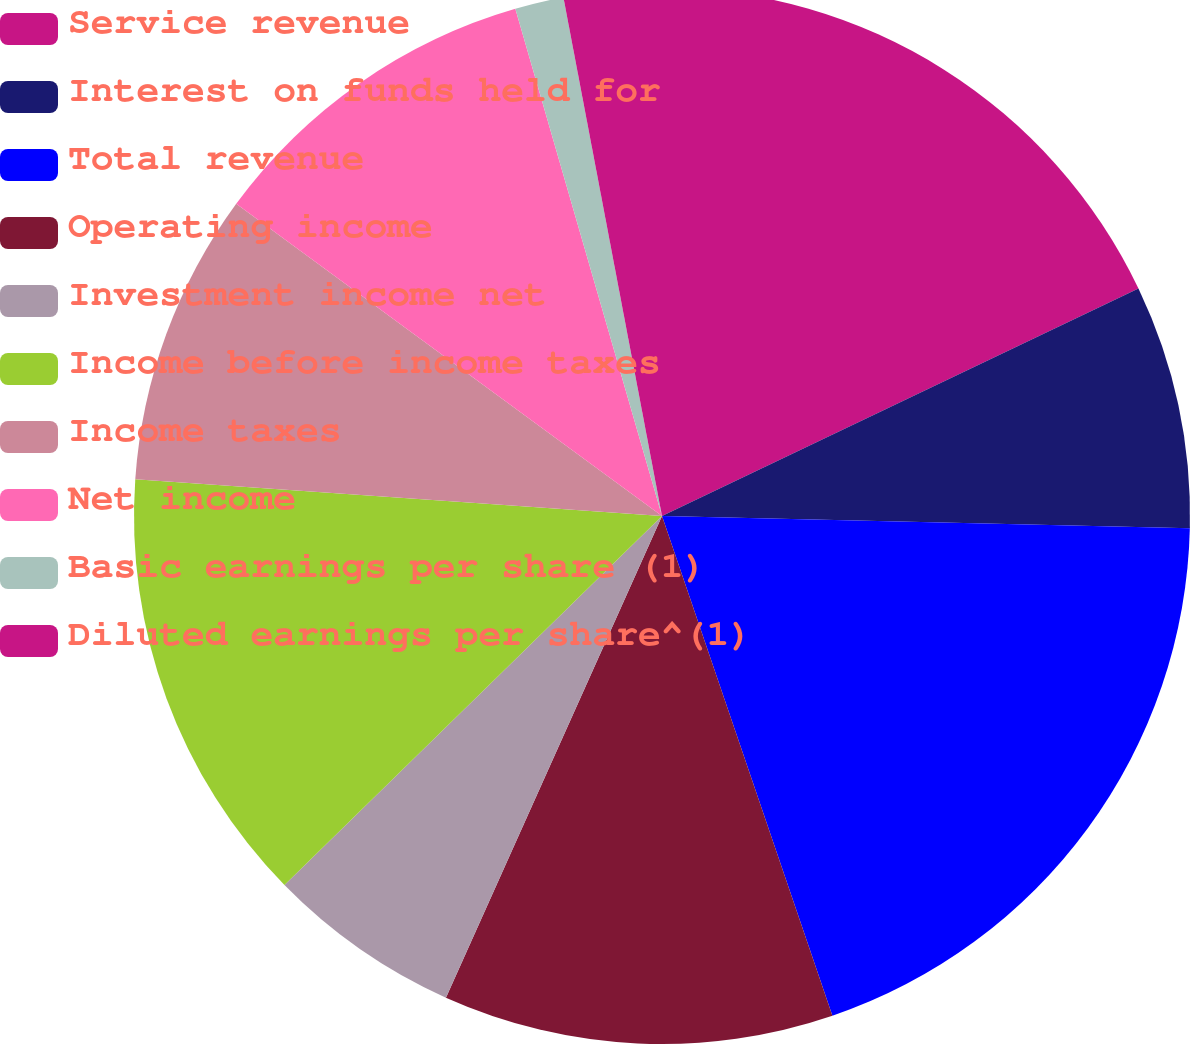<chart> <loc_0><loc_0><loc_500><loc_500><pie_chart><fcel>Service revenue<fcel>Interest on funds held for<fcel>Total revenue<fcel>Operating income<fcel>Investment income net<fcel>Income before income taxes<fcel>Income taxes<fcel>Net income<fcel>Basic earnings per share (1)<fcel>Diluted earnings per share^(1)<nl><fcel>17.91%<fcel>7.46%<fcel>19.4%<fcel>11.94%<fcel>5.97%<fcel>13.43%<fcel>8.96%<fcel>10.45%<fcel>1.49%<fcel>2.99%<nl></chart> 